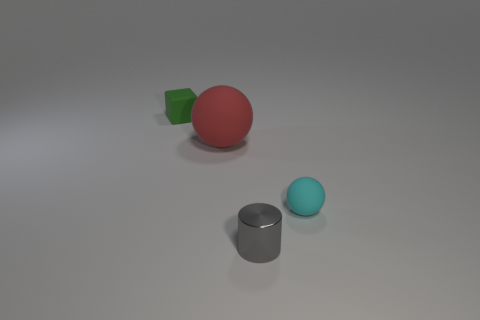Add 3 small matte cubes. How many objects exist? 7 Subtract 0 green balls. How many objects are left? 4 Subtract all tiny balls. Subtract all small red rubber spheres. How many objects are left? 3 Add 3 gray things. How many gray things are left? 4 Add 1 matte cubes. How many matte cubes exist? 2 